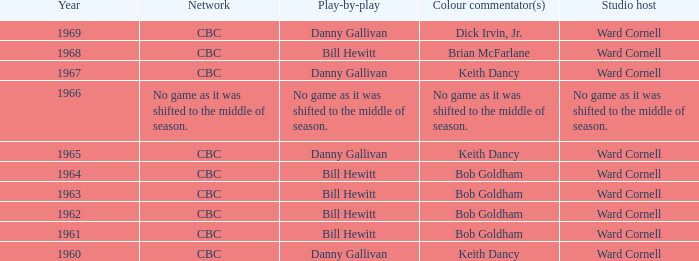Who delivered the play by play commentary in conjunction with studio host ward cornell? Danny Gallivan, Bill Hewitt, Danny Gallivan, Danny Gallivan, Bill Hewitt, Bill Hewitt, Bill Hewitt, Bill Hewitt, Danny Gallivan. 